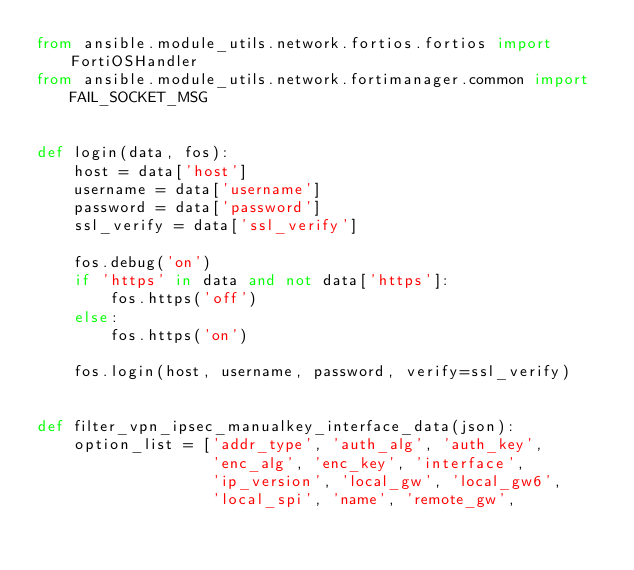Convert code to text. <code><loc_0><loc_0><loc_500><loc_500><_Python_>from ansible.module_utils.network.fortios.fortios import FortiOSHandler
from ansible.module_utils.network.fortimanager.common import FAIL_SOCKET_MSG


def login(data, fos):
    host = data['host']
    username = data['username']
    password = data['password']
    ssl_verify = data['ssl_verify']

    fos.debug('on')
    if 'https' in data and not data['https']:
        fos.https('off')
    else:
        fos.https('on')

    fos.login(host, username, password, verify=ssl_verify)


def filter_vpn_ipsec_manualkey_interface_data(json):
    option_list = ['addr_type', 'auth_alg', 'auth_key',
                   'enc_alg', 'enc_key', 'interface',
                   'ip_version', 'local_gw', 'local_gw6',
                   'local_spi', 'name', 'remote_gw',</code> 